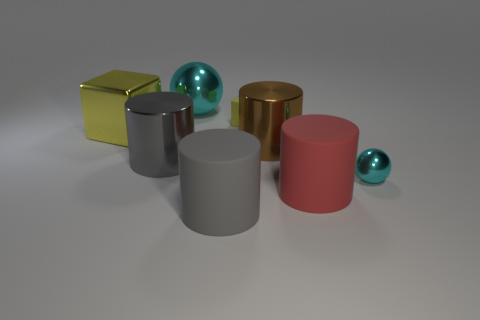Subtract all brown cylinders. How many cylinders are left? 3 Add 2 small purple shiny objects. How many objects exist? 10 Subtract 2 cylinders. How many cylinders are left? 2 Subtract all brown cylinders. How many cylinders are left? 3 Subtract all balls. How many objects are left? 6 Add 2 yellow things. How many yellow things are left? 4 Add 7 gray metallic things. How many gray metallic things exist? 8 Subtract 1 cyan spheres. How many objects are left? 7 Subtract all purple spheres. Subtract all brown cubes. How many spheres are left? 2 Subtract all gray blocks. How many brown cylinders are left? 1 